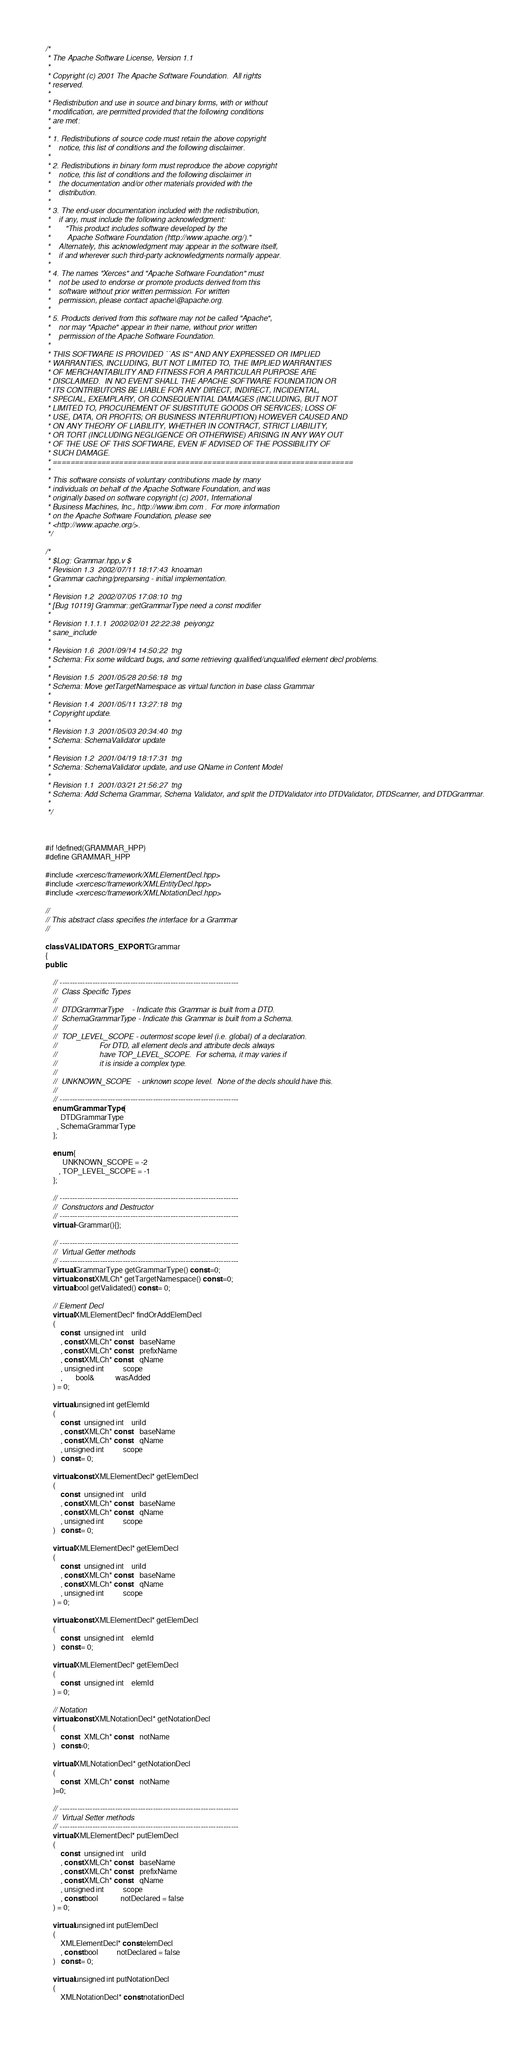<code> <loc_0><loc_0><loc_500><loc_500><_C++_>/*
 * The Apache Software License, Version 1.1
 *
 * Copyright (c) 2001 The Apache Software Foundation.  All rights
 * reserved.
 *
 * Redistribution and use in source and binary forms, with or without
 * modification, are permitted provided that the following conditions
 * are met:
 *
 * 1. Redistributions of source code must retain the above copyright
 *    notice, this list of conditions and the following disclaimer.
 *
 * 2. Redistributions in binary form must reproduce the above copyright
 *    notice, this list of conditions and the following disclaimer in
 *    the documentation and/or other materials provided with the
 *    distribution.
 *
 * 3. The end-user documentation included with the redistribution,
 *    if any, must include the following acknowledgment:
 *       "This product includes software developed by the
 *        Apache Software Foundation (http://www.apache.org/)."
 *    Alternately, this acknowledgment may appear in the software itself,
 *    if and wherever such third-party acknowledgments normally appear.
 *
 * 4. The names "Xerces" and "Apache Software Foundation" must
 *    not be used to endorse or promote products derived from this
 *    software without prior written permission. For written
 *    permission, please contact apache\@apache.org.
 *
 * 5. Products derived from this software may not be called "Apache",
 *    nor may "Apache" appear in their name, without prior written
 *    permission of the Apache Software Foundation.
 *
 * THIS SOFTWARE IS PROVIDED ``AS IS'' AND ANY EXPRESSED OR IMPLIED
 * WARRANTIES, INCLUDING, BUT NOT LIMITED TO, THE IMPLIED WARRANTIES
 * OF MERCHANTABILITY AND FITNESS FOR A PARTICULAR PURPOSE ARE
 * DISCLAIMED.  IN NO EVENT SHALL THE APACHE SOFTWARE FOUNDATION OR
 * ITS CONTRIBUTORS BE LIABLE FOR ANY DIRECT, INDIRECT, INCIDENTAL,
 * SPECIAL, EXEMPLARY, OR CONSEQUENTIAL DAMAGES (INCLUDING, BUT NOT
 * LIMITED TO, PROCUREMENT OF SUBSTITUTE GOODS OR SERVICES; LOSS OF
 * USE, DATA, OR PROFITS; OR BUSINESS INTERRUPTION) HOWEVER CAUSED AND
 * ON ANY THEORY OF LIABILITY, WHETHER IN CONTRACT, STRICT LIABILITY,
 * OR TORT (INCLUDING NEGLIGENCE OR OTHERWISE) ARISING IN ANY WAY OUT
 * OF THE USE OF THIS SOFTWARE, EVEN IF ADVISED OF THE POSSIBILITY OF
 * SUCH DAMAGE.
 * ====================================================================
 *
 * This software consists of voluntary contributions made by many
 * individuals on behalf of the Apache Software Foundation, and was
 * originally based on software copyright (c) 2001, International
 * Business Machines, Inc., http://www.ibm.com .  For more information
 * on the Apache Software Foundation, please see
 * <http://www.apache.org/>.
 */

/*
 * $Log: Grammar.hpp,v $
 * Revision 1.3  2002/07/11 18:17:43  knoaman
 * Grammar caching/preparsing - initial implementation.
 *
 * Revision 1.2  2002/07/05 17:08:10  tng
 * [Bug 10119] Grammar::getGrammarType need a const modifier
 *
 * Revision 1.1.1.1  2002/02/01 22:22:38  peiyongz
 * sane_include
 *
 * Revision 1.6  2001/09/14 14:50:22  tng
 * Schema: Fix some wildcard bugs, and some retrieving qualified/unqualified element decl problems.
 *
 * Revision 1.5  2001/05/28 20:56:18  tng
 * Schema: Move getTargetNamespace as virtual function in base class Grammar
 *
 * Revision 1.4  2001/05/11 13:27:18  tng
 * Copyright update.
 *
 * Revision 1.3  2001/05/03 20:34:40  tng
 * Schema: SchemaValidator update
 *
 * Revision 1.2  2001/04/19 18:17:31  tng
 * Schema: SchemaValidator update, and use QName in Content Model
 *
 * Revision 1.1  2001/03/21 21:56:27  tng
 * Schema: Add Schema Grammar, Schema Validator, and split the DTDValidator into DTDValidator, DTDScanner, and DTDGrammar.
 *
 */



#if !defined(GRAMMAR_HPP)
#define GRAMMAR_HPP

#include <xercesc/framework/XMLElementDecl.hpp>
#include <xercesc/framework/XMLEntityDecl.hpp>
#include <xercesc/framework/XMLNotationDecl.hpp>

//
// This abstract class specifies the interface for a Grammar
//

class VALIDATORS_EXPORT Grammar
{
public:

    // -----------------------------------------------------------------------
    //  Class Specific Types
    //
    //  DTDGrammarType    - Indicate this Grammar is built from a DTD.
    //  SchemaGrammarType - Indicate this Grammar is built from a Schema.
    //
    //  TOP_LEVEL_SCOPE - outermost scope level (i.e. global) of a declaration.
    //                    For DTD, all element decls and attribute decls always
    //                    have TOP_LEVEL_SCOPE.  For schema, it may varies if
    //                    it is inside a complex type.
    //
    //  UNKNOWN_SCOPE   - unknown scope level.  None of the decls should have this.
    //
    // -----------------------------------------------------------------------
    enum GrammarType {
        DTDGrammarType
      , SchemaGrammarType
    };

    enum {
         UNKNOWN_SCOPE = -2
       , TOP_LEVEL_SCOPE = -1
    };

    // -----------------------------------------------------------------------
    //  Constructors and Destructor
    // -----------------------------------------------------------------------
    virtual ~Grammar(){};

    // -----------------------------------------------------------------------
    //  Virtual Getter methods
    // -----------------------------------------------------------------------
    virtual GrammarType getGrammarType() const =0;
    virtual const XMLCh* getTargetNamespace() const =0;
    virtual bool getValidated() const = 0;

    // Element Decl
    virtual XMLElementDecl* findOrAddElemDecl
    (
        const   unsigned int    uriId
        , const XMLCh* const    baseName
        , const XMLCh* const    prefixName
        , const XMLCh* const    qName
        , unsigned int          scope
        ,       bool&           wasAdded
    ) = 0;

    virtual unsigned int getElemId
    (
        const   unsigned int    uriId
        , const XMLCh* const    baseName
        , const XMLCh* const    qName
        , unsigned int          scope
    )   const = 0;

    virtual const XMLElementDecl* getElemDecl
    (
        const   unsigned int    uriId
        , const XMLCh* const    baseName
        , const XMLCh* const    qName
        , unsigned int          scope
    )   const = 0;

    virtual XMLElementDecl* getElemDecl
    (
        const   unsigned int    uriId
        , const XMLCh* const    baseName
        , const XMLCh* const    qName
        , unsigned int          scope
    ) = 0;

    virtual const XMLElementDecl* getElemDecl
    (
        const   unsigned int    elemId
    )   const = 0;

    virtual XMLElementDecl* getElemDecl
    (
        const   unsigned int    elemId
    ) = 0;

    // Notation
    virtual const XMLNotationDecl* getNotationDecl
    (
        const   XMLCh* const    notName
    )   const=0;

    virtual XMLNotationDecl* getNotationDecl
    (
        const   XMLCh* const    notName
    )=0;

    // -----------------------------------------------------------------------
    //  Virtual Setter methods
    // -----------------------------------------------------------------------
    virtual XMLElementDecl* putElemDecl
    (
        const   unsigned int    uriId
        , const XMLCh* const    baseName
        , const XMLCh* const    prefixName
        , const XMLCh* const    qName
        , unsigned int          scope
        , const bool            notDeclared = false
    ) = 0;

    virtual unsigned int putElemDecl
    (
        XMLElementDecl* const elemDecl
        , const bool          notDeclared = false
    )   const = 0;

    virtual unsigned int putNotationDecl
    (
        XMLNotationDecl* const notationDecl</code> 